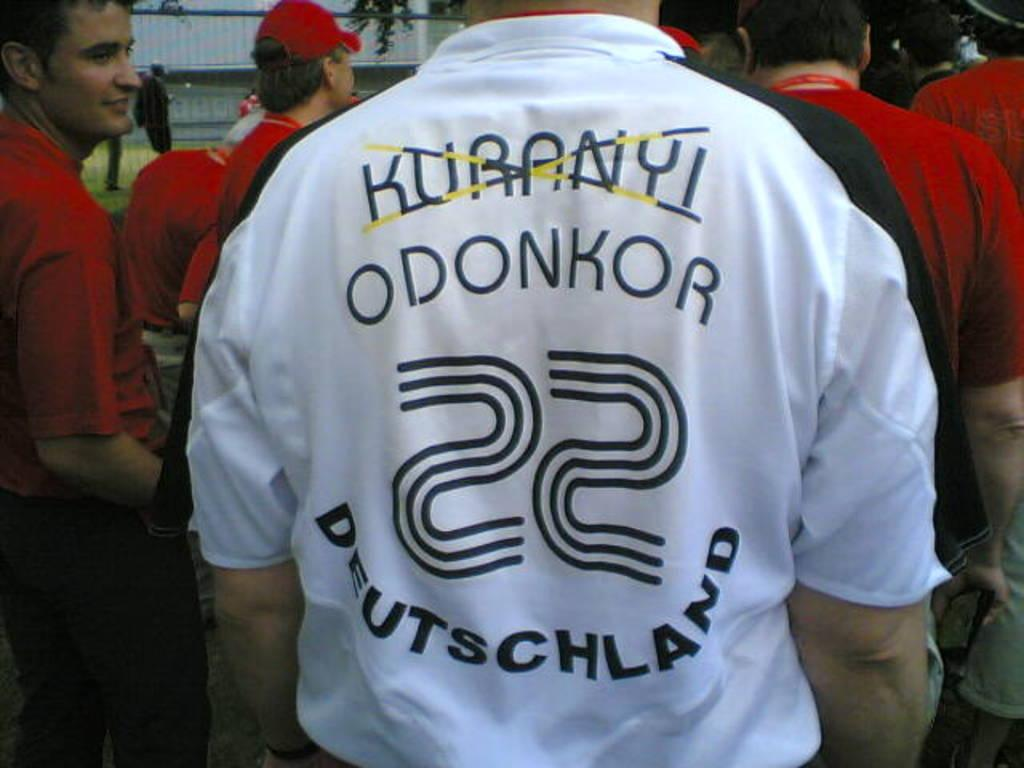<image>
Provide a brief description of the given image. the number 22 that is on a person's shirt 